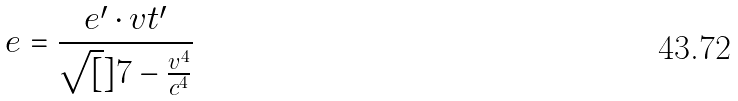Convert formula to latex. <formula><loc_0><loc_0><loc_500><loc_500>e = \frac { e ^ { \prime } \cdot v t ^ { \prime } } { \sqrt { [ } ] { 7 - \frac { v ^ { 4 } } { c ^ { 4 } } } }</formula> 